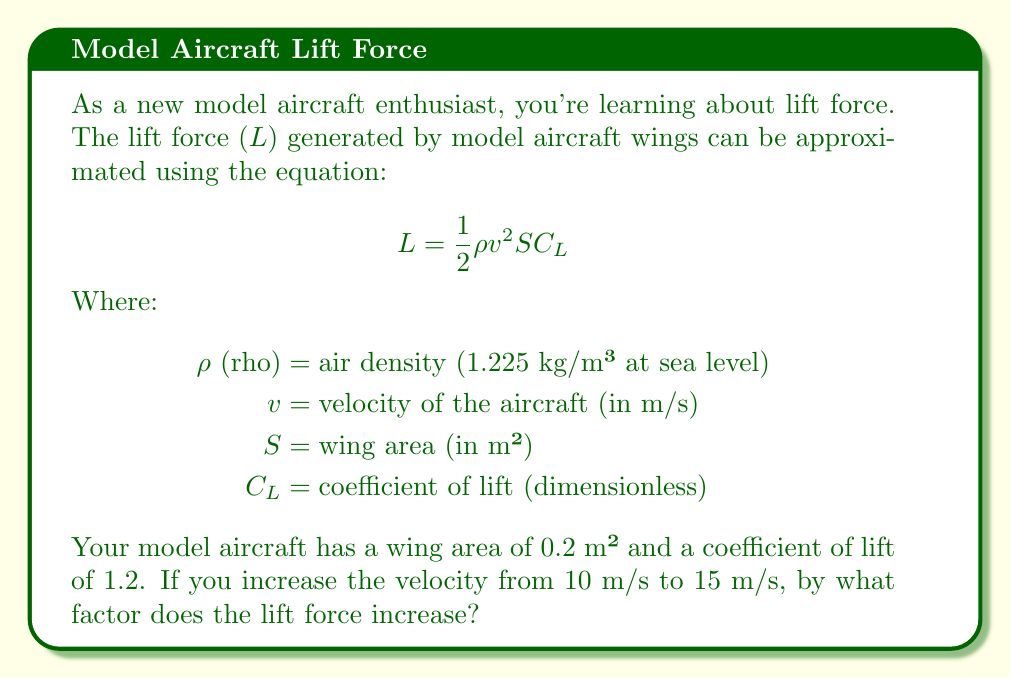Can you solve this math problem? Let's approach this step-by-step:

1) First, we need to calculate the lift force at both velocities using the given equation.

2) For v = 10 m/s:
   $$ L_1 = \frac{1}{2} \cdot 1.225 \cdot 10^2 \cdot 0.2 \cdot 1.2 $$

3) For v = 15 m/s:
   $$ L_2 = \frac{1}{2} \cdot 1.225 \cdot 15^2 \cdot 0.2 \cdot 1.2 $$

4) Notice that the only difference between these equations is the velocity term, which is squared.

5) To find the factor of increase, we can divide $L_2$ by $L_1$:

   $$ \frac{L_2}{L_1} = \frac{\frac{1}{2} \cdot 1.225 \cdot 15^2 \cdot 0.2 \cdot 1.2}{\frac{1}{2} \cdot 1.225 \cdot 10^2 \cdot 0.2 \cdot 1.2} $$

6) All terms except the velocity cancel out:

   $$ \frac{L_2}{L_1} = \frac{15^2}{10^2} = \frac{225}{100} = 2.25 $$

7) This means the lift force increases by a factor of 2.25 when the velocity increases from 10 m/s to 15 m/s.

8) We can also express this using exponents:
   $$ \frac{L_2}{L_1} = (\frac{15}{10})^2 = 1.5^2 = 2.25 $$

This demonstrates that the lift force is proportional to the square of the velocity.
Answer: The lift force increases by a factor of 2.25 when the velocity increases from 10 m/s to 15 m/s. 